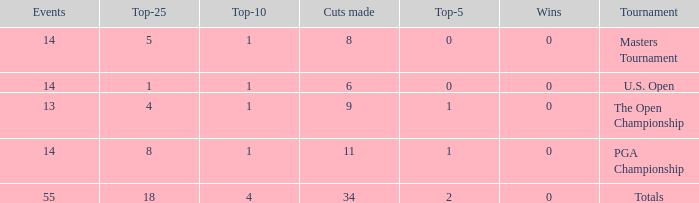What is the average top-5 when the cuts made is more than 34? None. 